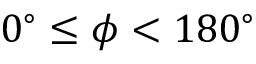Convert formula to latex. <formula><loc_0><loc_0><loc_500><loc_500>0 ^ { \circ } \leq \phi < 1 8 0 ^ { \circ }</formula> 